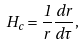Convert formula to latex. <formula><loc_0><loc_0><loc_500><loc_500>H _ { c } = \frac { 1 } { r } \frac { d r } { d \tau } ,</formula> 